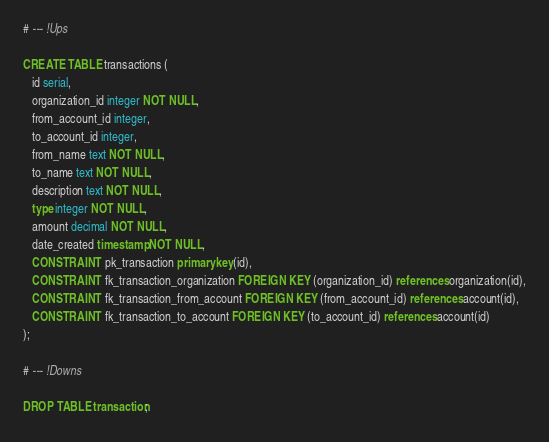Convert code to text. <code><loc_0><loc_0><loc_500><loc_500><_SQL_># --- !Ups

CREATE TABLE transactions (
   id serial,
   organization_id integer NOT NULL,
   from_account_id integer,
   to_account_id integer,
   from_name text NOT NULL,
   to_name text NOT NULL,
   description text NOT NULL,
   type integer NOT NULL,
   amount decimal NOT NULL,
   date_created timestamp NOT NULL,
   CONSTRAINT pk_transaction primary key(id),
   CONSTRAINT fk_transaction_organization FOREIGN KEY (organization_id) references organization(id),
   CONSTRAINT fk_transaction_from_account FOREIGN KEY (from_account_id) references account(id),
   CONSTRAINT fk_transaction_to_account FOREIGN KEY (to_account_id) references account(id)
);

# --- !Downs

DROP TABLE transaction;</code> 